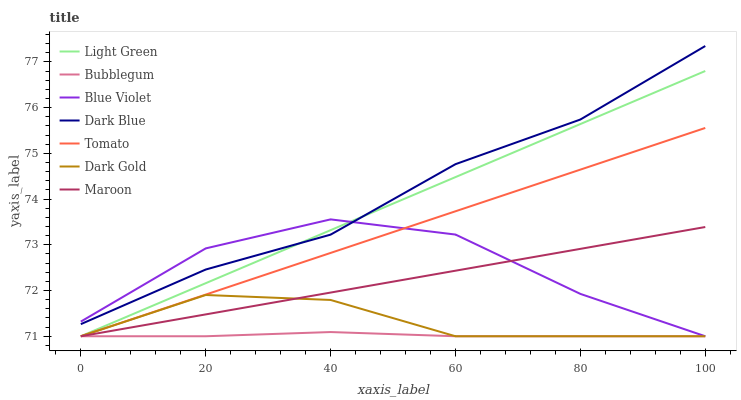Does Bubblegum have the minimum area under the curve?
Answer yes or no. Yes. Does Dark Blue have the maximum area under the curve?
Answer yes or no. Yes. Does Dark Gold have the minimum area under the curve?
Answer yes or no. No. Does Dark Gold have the maximum area under the curve?
Answer yes or no. No. Is Light Green the smoothest?
Answer yes or no. Yes. Is Blue Violet the roughest?
Answer yes or no. Yes. Is Dark Gold the smoothest?
Answer yes or no. No. Is Dark Gold the roughest?
Answer yes or no. No. Does Tomato have the lowest value?
Answer yes or no. Yes. Does Dark Blue have the lowest value?
Answer yes or no. No. Does Dark Blue have the highest value?
Answer yes or no. Yes. Does Dark Gold have the highest value?
Answer yes or no. No. Is Tomato less than Dark Blue?
Answer yes or no. Yes. Is Dark Blue greater than Bubblegum?
Answer yes or no. Yes. Does Blue Violet intersect Light Green?
Answer yes or no. Yes. Is Blue Violet less than Light Green?
Answer yes or no. No. Is Blue Violet greater than Light Green?
Answer yes or no. No. Does Tomato intersect Dark Blue?
Answer yes or no. No. 